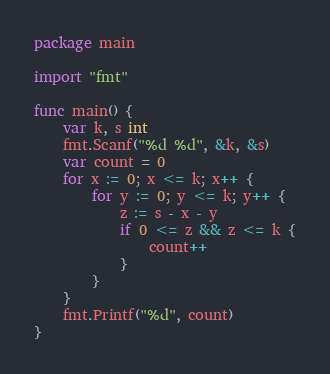<code> <loc_0><loc_0><loc_500><loc_500><_Go_>package main

import "fmt"

func main() {
	var k, s int
	fmt.Scanf("%d %d", &k, &s)
	var count = 0
	for x := 0; x <= k; x++ {
		for y := 0; y <= k; y++ {
			z := s - x - y
			if 0 <= z && z <= k {
				count++
			}
		}
	}
	fmt.Printf("%d", count)
}
</code> 